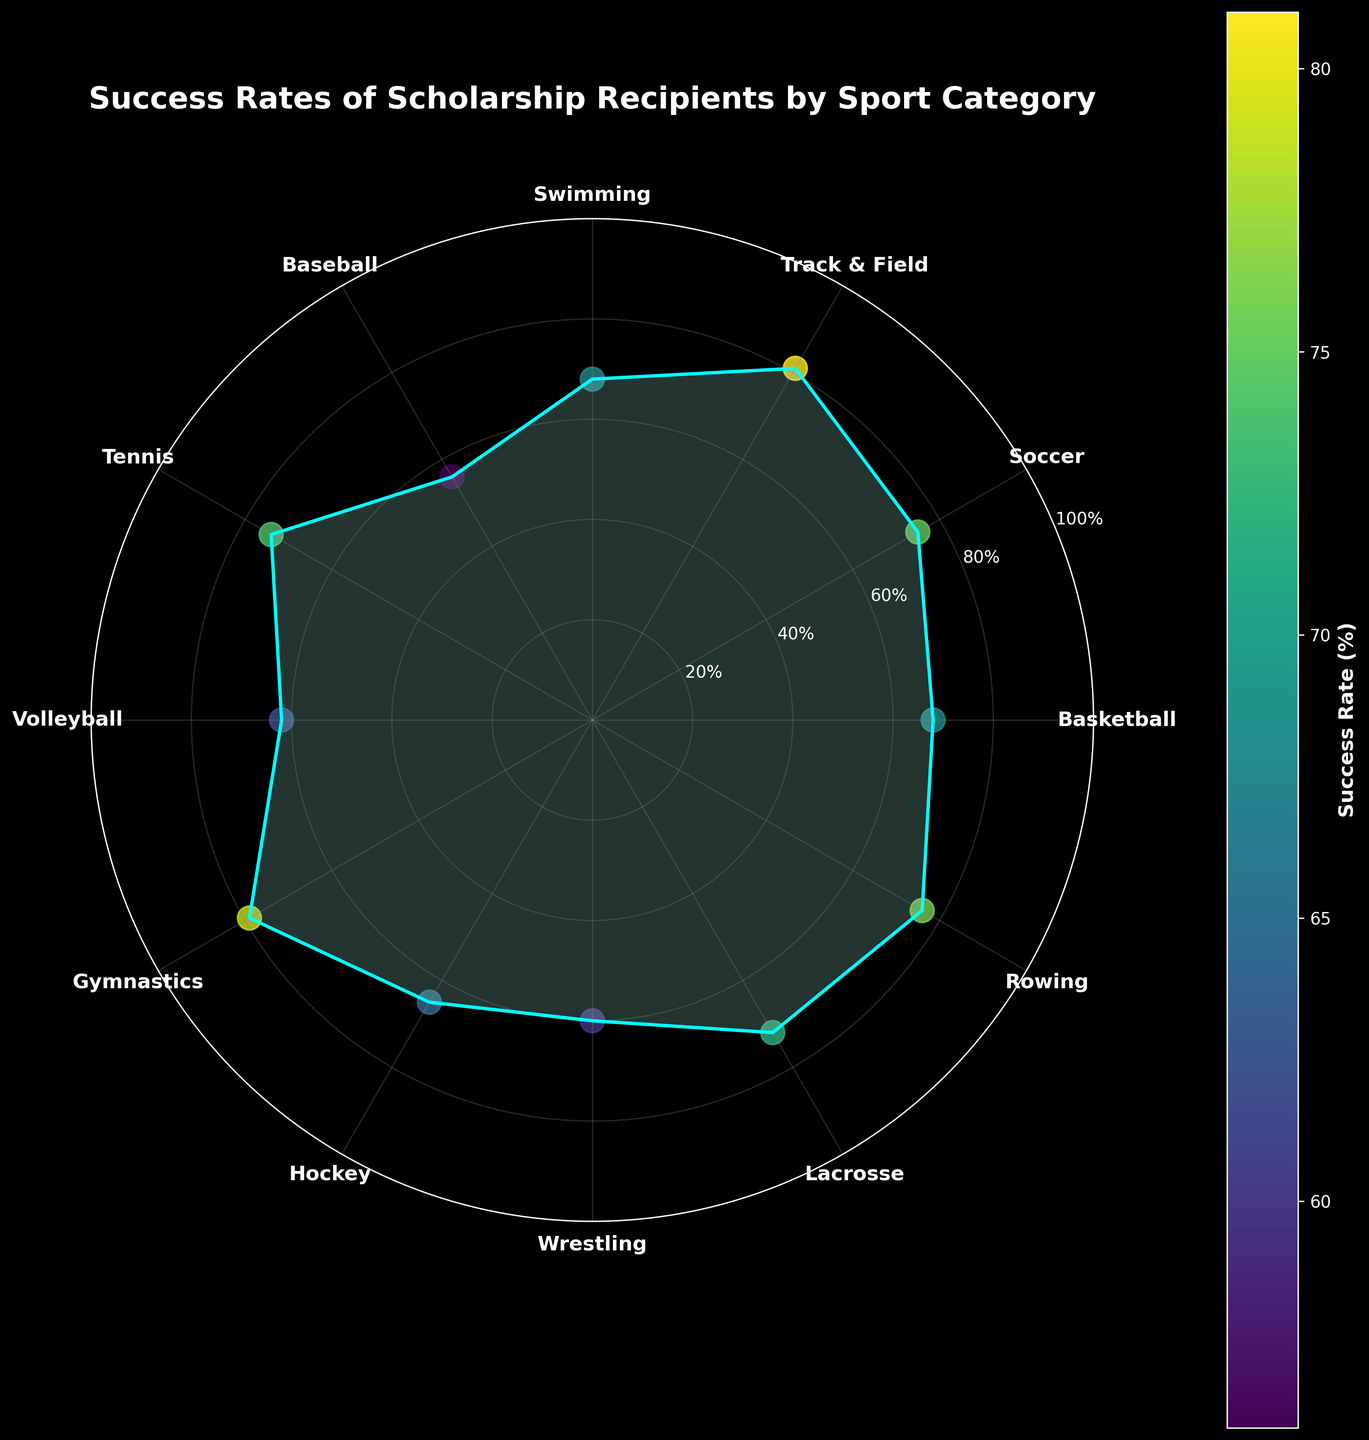How many sport categories are represented in the figure? Count the number of distinct sport categories shown on the figure. It totals up to 12 categories: Basketball, Soccer, Track & Field, Swimming, Baseball, Tennis, Volleyball, Gymnastics, Hockey, Wrestling, Lacrosse, and Rowing.
Answer: 12 What is the title of the figure? The title is usually found at the top of the chart. For this figure, it is clearly stated.
Answer: Success Rates of Scholarship Recipients by Sport Category Which sport category has the highest success rate? Locate the sport category on the polar scatter chart with the highest value on the radial axis. Track & Field has the highest success rate, reaching 81%.
Answer: Track & Field What is the difference in success rate between Basketball and Baseball? Subtract the success rate of Baseball (56%) from that of Basketball (68%). The difference is calculated as 68 - 56 = 12%.
Answer: 12% Which two sports have the same success rate? Identify the sports on the polar scatter chart with identical radial values. Both Basketball and Swimming have success rates of 68%.
Answer: Basketball and Swimming What is the average success rate of all the sport categories represented? Sum all the success rate values and divide by the number of categories (12). The calculation is (68 + 75 + 81 + 68 + 56 + 74 + 62 + 79 + 65 + 60 + 72 + 76) / 12 = 72.
Answer: 72 How many sports have a success rate greater than 70%? Identify and count the sports with radial values above the 70% mark on the chart. Soccer, Track & Field, Tennis, Gymnastics, Lacrosse, and Rowing have success rates above 70%.
Answer: 6 Which sport has a success rate closest to 65%? Find the sport(s) whose success rate is nearest to 65%. Hockey, with a success rate of 65%, is the closest.
Answer: Hockey What is the range of success rates represented in the figure? Calculate the difference between the highest and lowest success rates. The highest is Track & Field at 81% and the lowest is Baseball at 56%, so the range is 81 - 56 = 25%.
Answer: 25% Between Volleyball and Wrestling, which sport has a higher success rate? Compare the radial values of Volleyball (62%) and Wrestling (60%). Volleyball has a higher success rate.
Answer: Volleyball 